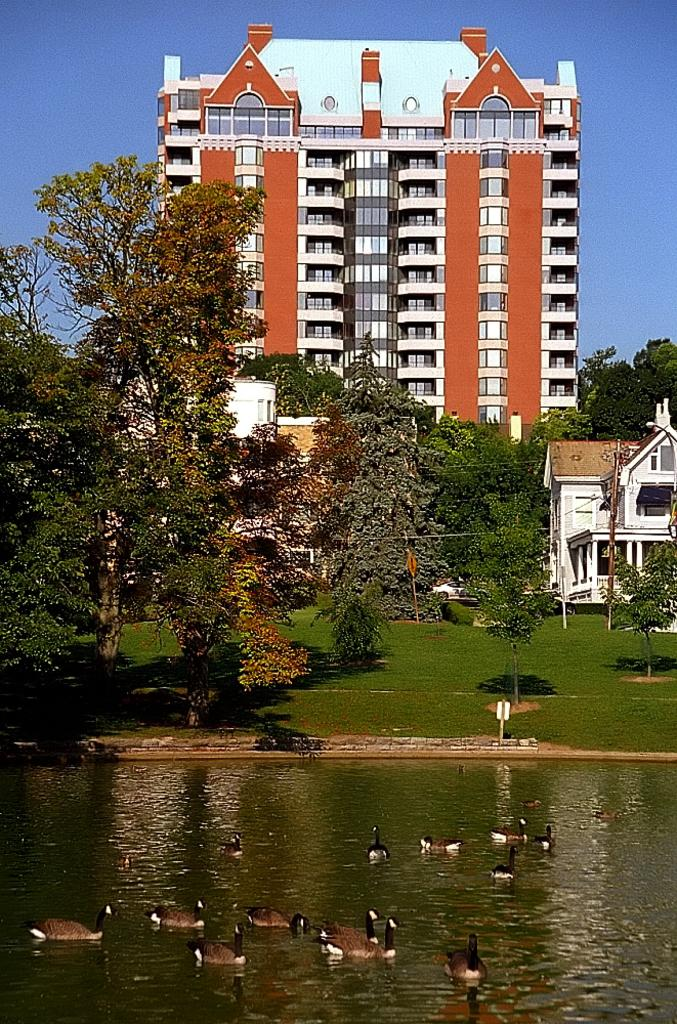What animals can be seen in the image? There are ducks floating on water in the image. What type of vegetation is visible in the image? There is grass visible in the image, as well as trees. What structures are present in the image? A current pole, houses, and a building are present in the image. What is the color of the sky in the background? The sky in the background is blue. What type of angle is being used to measure the impulse of the pump in the image? There is no angle, impulse, or pump present in the image. 